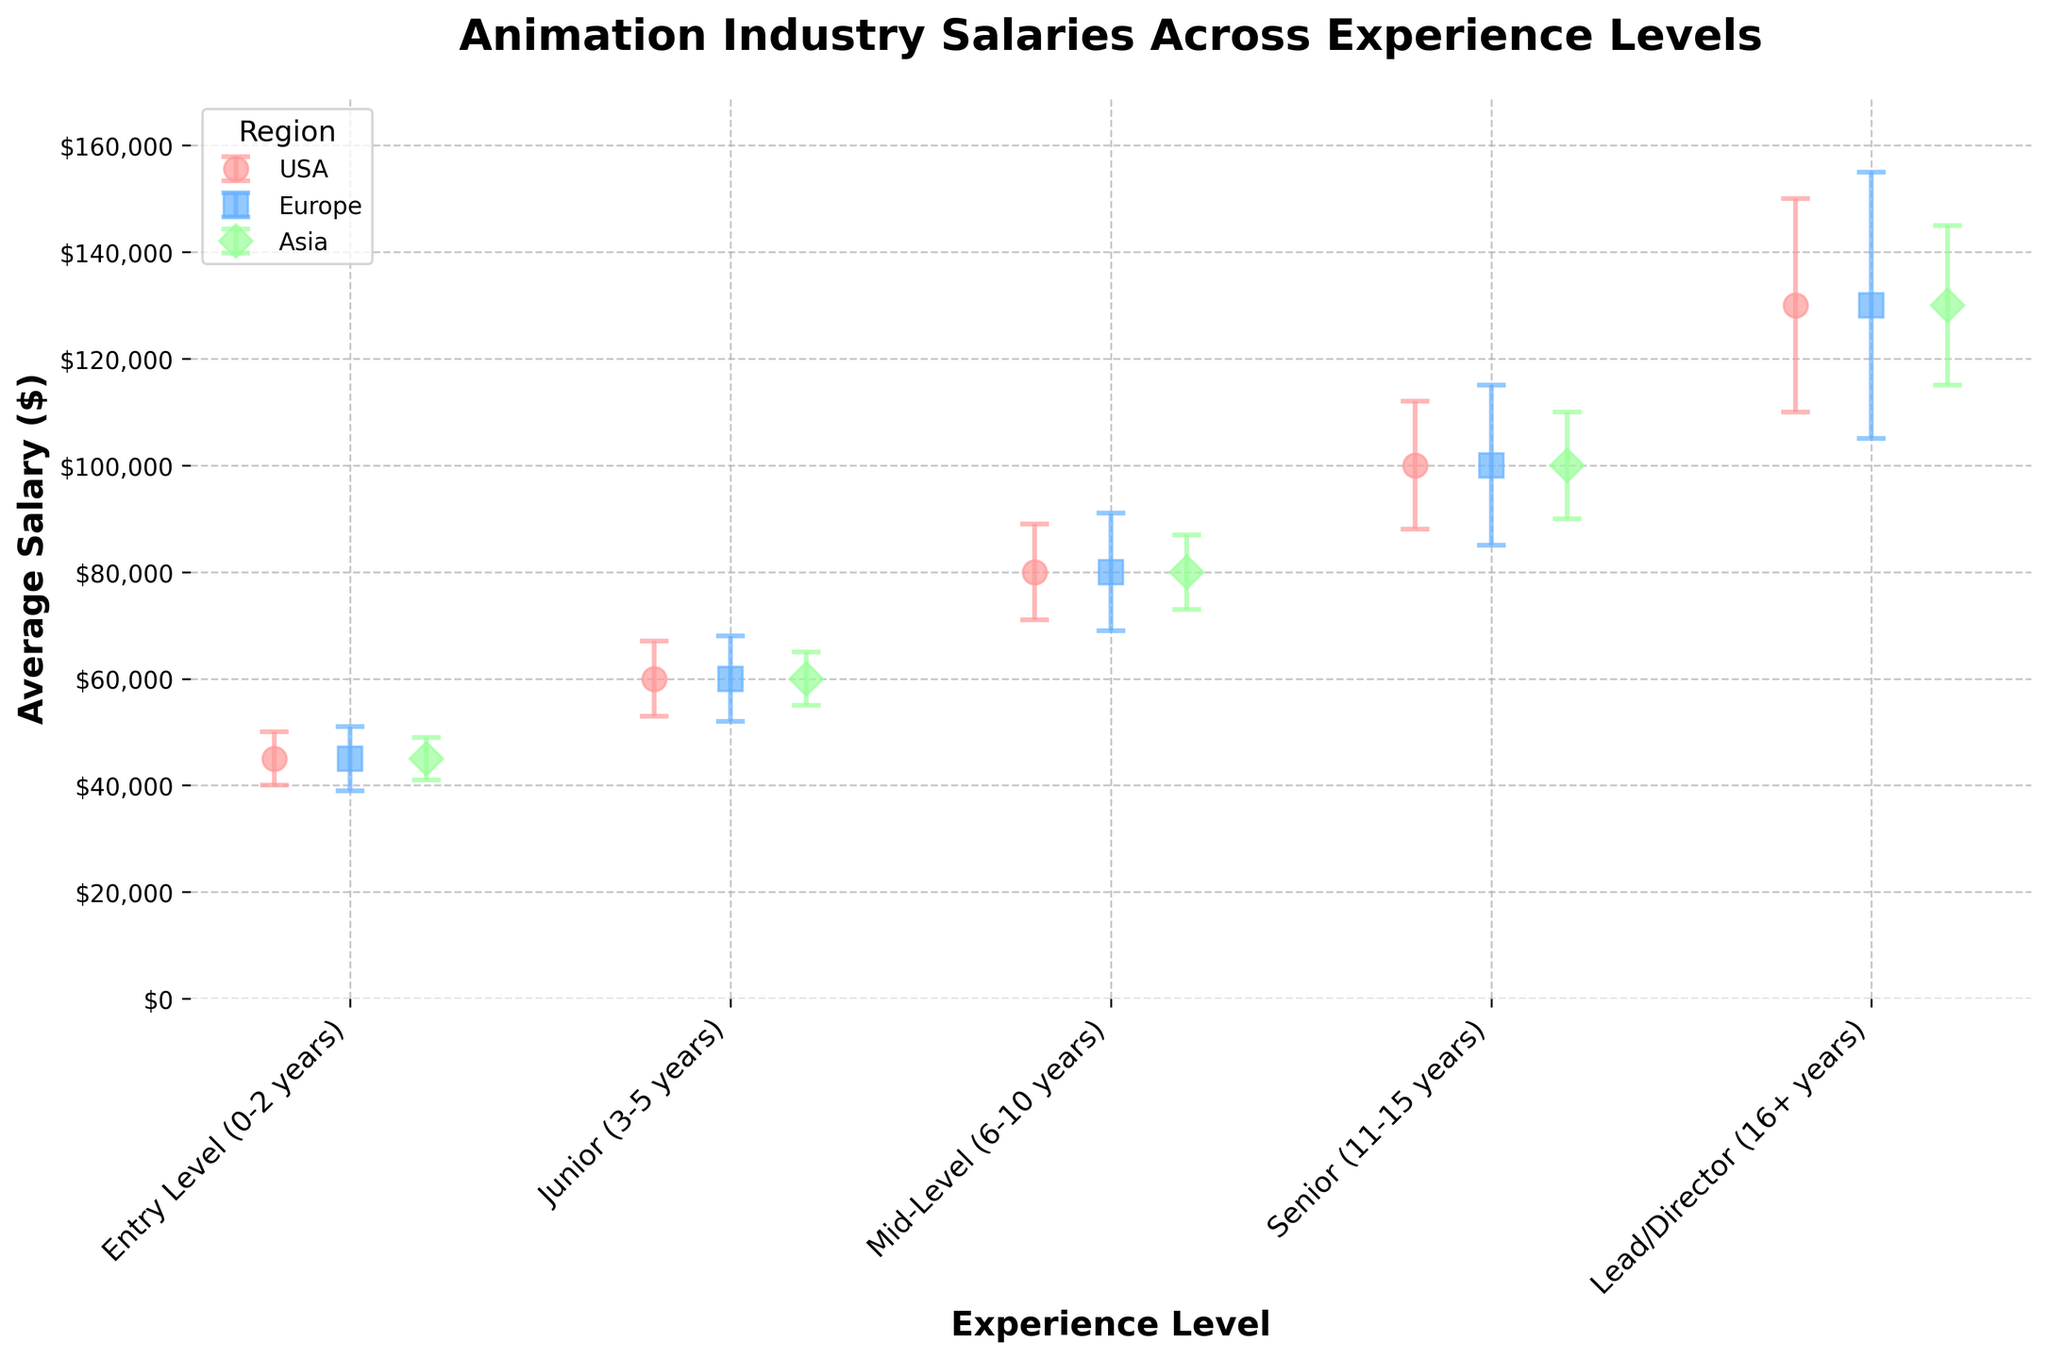What is the title of the figure? The title can be found at the top of the figure. It clearly states the main topic being visualized.
Answer: Animation Industry Salaries Across Experience Levels How many different experience levels are shown in the figure? Count the number of distinct labels on the x-axis representing the experience levels.
Answer: 5 What color represents the salary variation for Europe? Identify the color used for the error bars or data points labeled as Europe in the legend.
Answer: Blue Which experience level has the highest average salary? Look for the data point with the highest position on the y-axis.
Answer: Lead/Director (16+ years) How does the salary error in Asia for Mid-Level compare to that in Europe? Compare the length of the error bars for the "Mid-Level" position between Asia and Europe in the scatter plot.
Answer: Smaller in Asia What is the average salary for a Senior position (11-15 years)? Identify the data point labeled "Senior (11-15 years)" on the x-axis and read its corresponding y-axis value.
Answer: $100,000 Which region has the largest salary variation for an Entry Level position? Compare the length of the error bars for each region at the "Entry Level (0-2 years)" data point.
Answer: Europe By approximately what amount do the Lead/Director salaries vary in the USA? Look at the length of the error bar for the Lead/Director position in the USA region and read its value.
Answer: $20,000 Between which two experience levels is there the largest increase in average salary? Compare the differences in y-axis values between adjacent experience levels to find the largest increase.
Answer: Senior (11-15 years) to Lead/Director (16+ years) Do Junior positions have a higher average salary than Entry Level positions? Compare the y-axis values for "Junior (3-5 years)" and "Entry Level (0-2 years)" data points.
Answer: Yes 